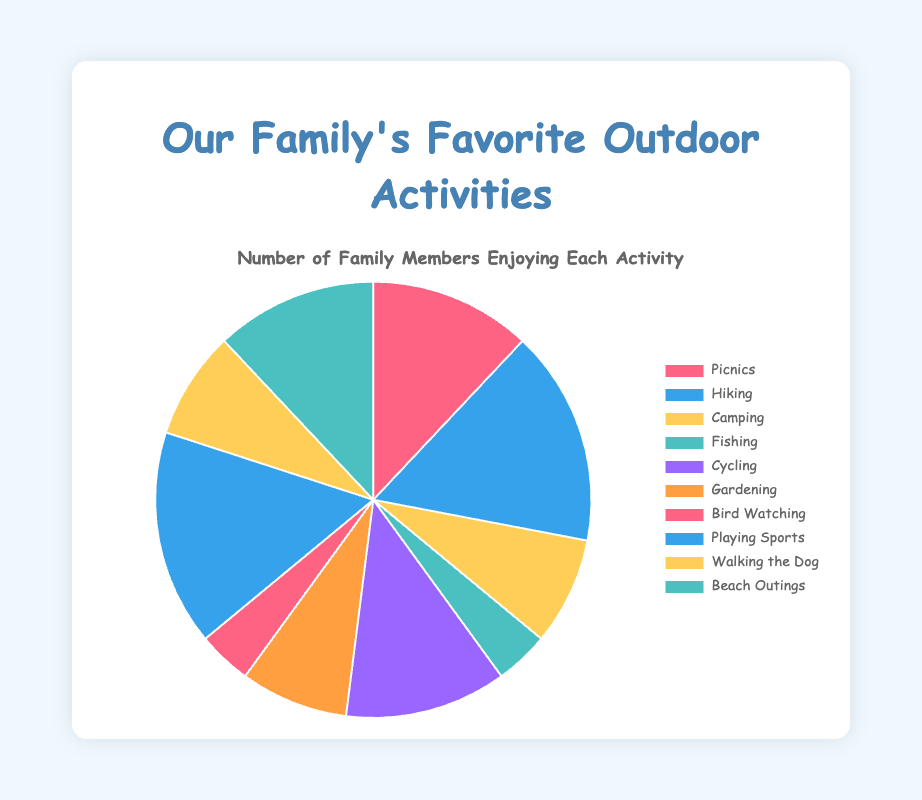What activity is enjoyed by the highest number of family members? The slice representing "Hiking" and "Playing Sports" are the largest ones, indicating they are enjoyed by the highest number of family members, with 4 each.
Answer: Hiking and Playing Sports How many family members enjoy activities involving nature (Gardening, Bird Watching, and Camping) in total? Add the numbers for Gardening (2), Bird Watching (1), and Camping (2). Total is 2 + 1 + 2 = 5.
Answer: 5 Are there more family members who enjoy Picnics or Cycling? Both the slices representing Picnics and Cycling are equally sized, indicating they are enjoyed by an equal number of family members (3 each).
Answer: They are equal Which activity has the least number of family members enjoying it? The smallest slices are for "Fishing" and "Bird Watching", each representing enjoyment by 1 family member.
Answer: Fishing and Bird Watching What is the combined number of family members who enjoy Beach Outings and Walking the Dog? Add the numbers for Beach Outings (3) and Walking the Dog (2). Total is 3 + 2 = 5.
Answer: 5 How many more family members enjoy Hiking compared to Camping? Subtract the number of family members who enjoy Camping (2) from those who enjoy Hiking (4). 4 - 2 = 2.
Answer: 2 Which activities are equally popular based on the number of family members engaging in them? The slices for Picnics, Cycling, and Beach Outings are equally sized, each indicating 3 family members. Similarly, Camping, Gardening, and Walking the Dog each have 2.
Answer: Picnics, Cycling, and Beach Outings; Camping, Gardening, and Walking the Dog What is the ratio of family members who prefer Playing Sports to those who prefer Gardening? Divide the number of family members who enjoy Playing Sports (4) by those who enjoy Gardening (2). The ratio is 4/2 = 2:1.
Answer: 2:1 How does the number of family members who enjoy Bird Watching compare to those who enjoy Fishing? Both Bird Watching and Fishing slices indicate they are enjoyed by 1 family member each.
Answer: They are equal 